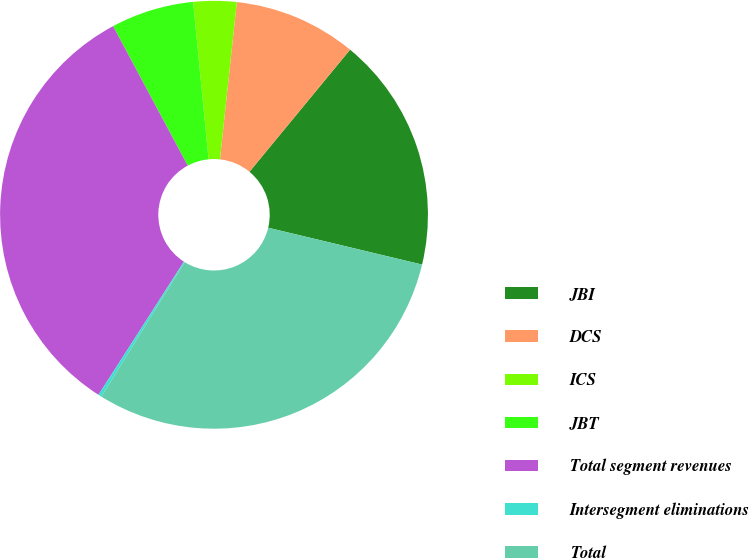Convert chart to OTSL. <chart><loc_0><loc_0><loc_500><loc_500><pie_chart><fcel>JBI<fcel>DCS<fcel>ICS<fcel>JBT<fcel>Total segment revenues<fcel>Intersegment eliminations<fcel>Total<nl><fcel>17.77%<fcel>9.27%<fcel>3.26%<fcel>6.26%<fcel>33.1%<fcel>0.25%<fcel>30.09%<nl></chart> 